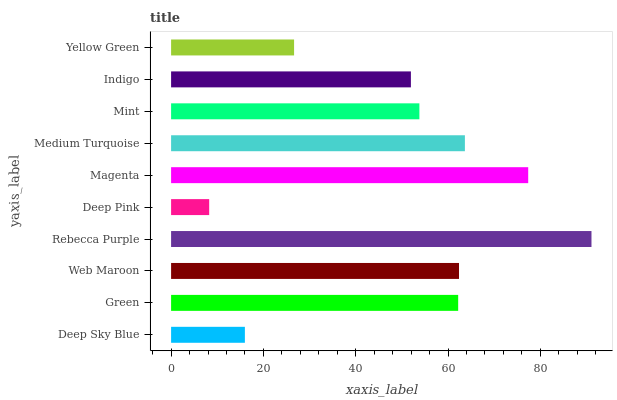Is Deep Pink the minimum?
Answer yes or no. Yes. Is Rebecca Purple the maximum?
Answer yes or no. Yes. Is Green the minimum?
Answer yes or no. No. Is Green the maximum?
Answer yes or no. No. Is Green greater than Deep Sky Blue?
Answer yes or no. Yes. Is Deep Sky Blue less than Green?
Answer yes or no. Yes. Is Deep Sky Blue greater than Green?
Answer yes or no. No. Is Green less than Deep Sky Blue?
Answer yes or no. No. Is Green the high median?
Answer yes or no. Yes. Is Mint the low median?
Answer yes or no. Yes. Is Rebecca Purple the high median?
Answer yes or no. No. Is Yellow Green the low median?
Answer yes or no. No. 